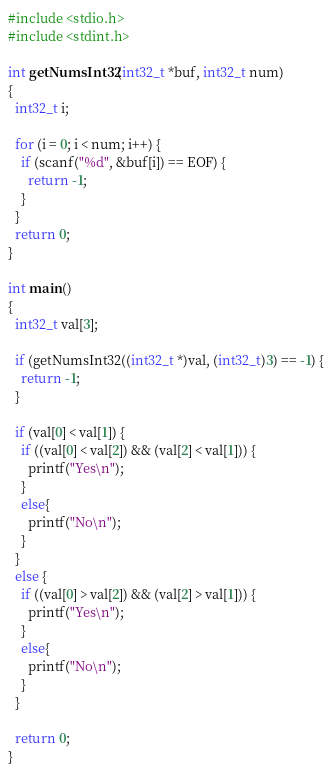Convert code to text. <code><loc_0><loc_0><loc_500><loc_500><_C_>#include <stdio.h>
#include <stdint.h>

int getNumsInt32(int32_t *buf, int32_t num)
{
  int32_t i;

  for (i = 0; i < num; i++) {
    if (scanf("%d", &buf[i]) == EOF) {
      return -1;
    }
  }
  return 0;
}

int main()
{
  int32_t val[3];

  if (getNumsInt32((int32_t *)val, (int32_t)3) == -1) {
    return -1;
  }

  if (val[0] < val[1]) {
    if ((val[0] < val[2]) && (val[2] < val[1])) {
      printf("Yes\n");
    }
    else{
      printf("No\n");
    }
  }
  else {
    if ((val[0] > val[2]) && (val[2] > val[1])) {
      printf("Yes\n");
    }
    else{
      printf("No\n");
    }
  } 

  return 0;
}</code> 